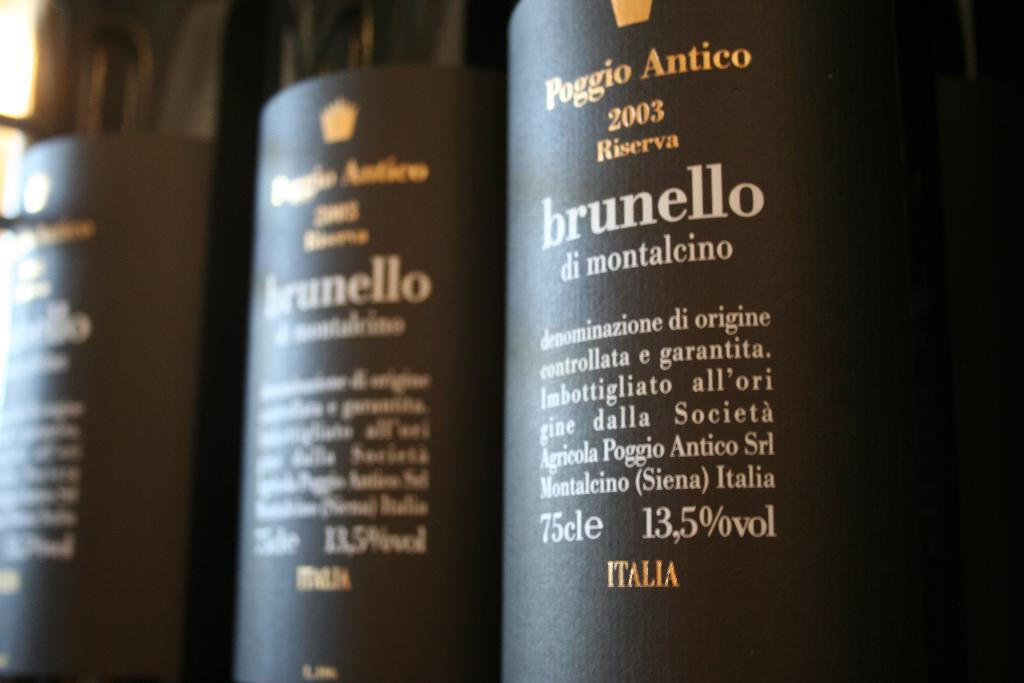<image>
Provide a brief description of the given image. Bottles of Italian wine marked brunello di motalcino. 